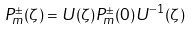<formula> <loc_0><loc_0><loc_500><loc_500>P ^ { \pm } _ { m } ( \zeta ) = U ( \zeta ) P ^ { \pm } _ { m } ( 0 ) U ^ { - 1 } ( \zeta )</formula> 